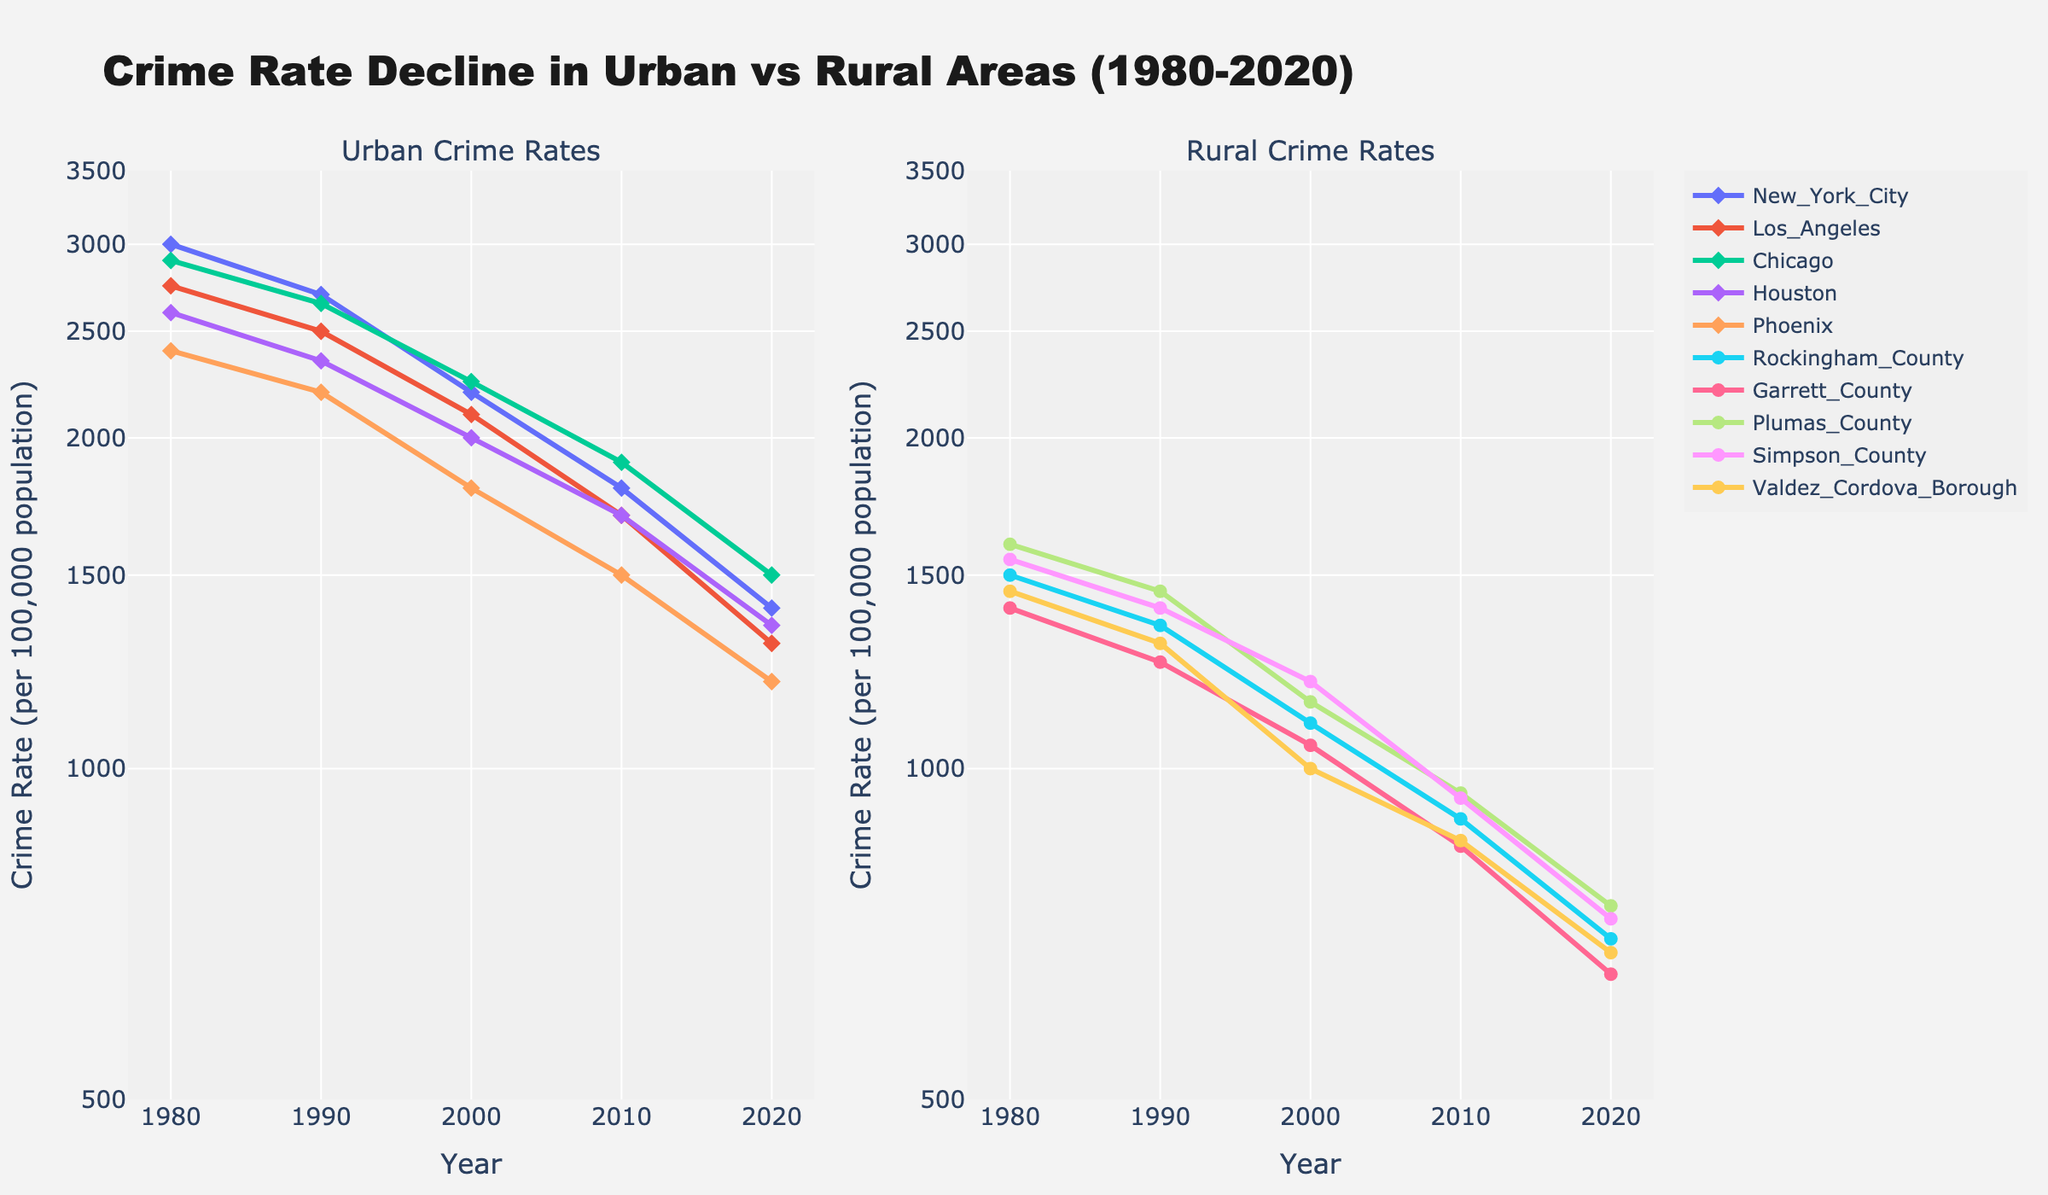What is the title of the figure? The title is located at the top of the figure and provides an overview of what the figure represents.
Answer: Crime Rate Decline in Urban vs Rural Areas (1980-2020) Which city had the highest crime rate in 1980 among the urban areas? To determine this, we compare the crime rates of New York City, Los Angeles, Chicago, Houston, and Phoenix for the year 1980. New York City had 3000, Los Angeles had 2750, Chicago had 2900, Houston had 2600, and Phoenix had 2400. New York City had the highest value.
Answer: New York City How many data points are displayed for each location? Each city's and county's data spans from 1980 to 2020 at intervals of a decade, resulting in a total of 5 data points per location.
Answer: 5 What is the relationship between the crime rates in New York City and Garrett County in 2020? By comparing the crime rates in 2020, we see New York City's crime rate is 1400 and Garrett County's is 650. New York City's crime rate is more than twice that of Garrett County.
Answer: More than twice Which rural county saw the steepest decline in crime rate from 1980 to 2020? To determine this, compare the decline in crime rates over the period for all rural counties. Rockingham County dropped from 1500 to 700, Garrett County from 1400 to 650, Plumas County from 1600 to 750, Simpson County from 1550 to 730, and Valdez-Cordova Borough from 1450 to 680. The greatest decline was in Plumas County.
Answer: Plumas County What's the median crime rate for urban areas in 2000? To find the median, list the crime rates in ascending order: Phoenix (1800), Houston (2000), Los Angeles (2100), Chicago (2250), and New York City (2200). The median is the middle value.
Answer: 2200 Which location had the smallest decline in crime rate between the years 1990 and 2000? To find this, calculate the decline for each location and identify the smallest value. New York City: 2700 to 2200 (500), Los Angeles: 2500 to 2100 (400), Chicago: 2650 to 2250 (400), Houston: 2350 to 2000 (350), Phoenix: 2200 to 1800 (400), Rockingham County: 1350 to 1100 (250), Garrett County: 1250 to 1050 (200), Plumas County: 1450 to 1150 (300), Simpson County: 1400 to 1200 (200), Valdez-Cordova Borough: 1300 to 1000 (300). Garrett and Simpson Counties had the smallest decline of 200.
Answer: Garrett County and Simpson County Which urban area had its crime rate reduced the most between 1980 and 2020? Calculate the difference between the 1980 and 2020 crime rates for each urban area and determine the greatest reduction. New York City: 3000 to 1400 (1600), Los Angeles: 2750 to 1300 (1450), Chicago: 2900 to 1500 (1400), Houston: 2600 to 1350 (1250), Phoenix: 2400 to 1200 (1200). New York City had the largest reduction.
Answer: New York City 